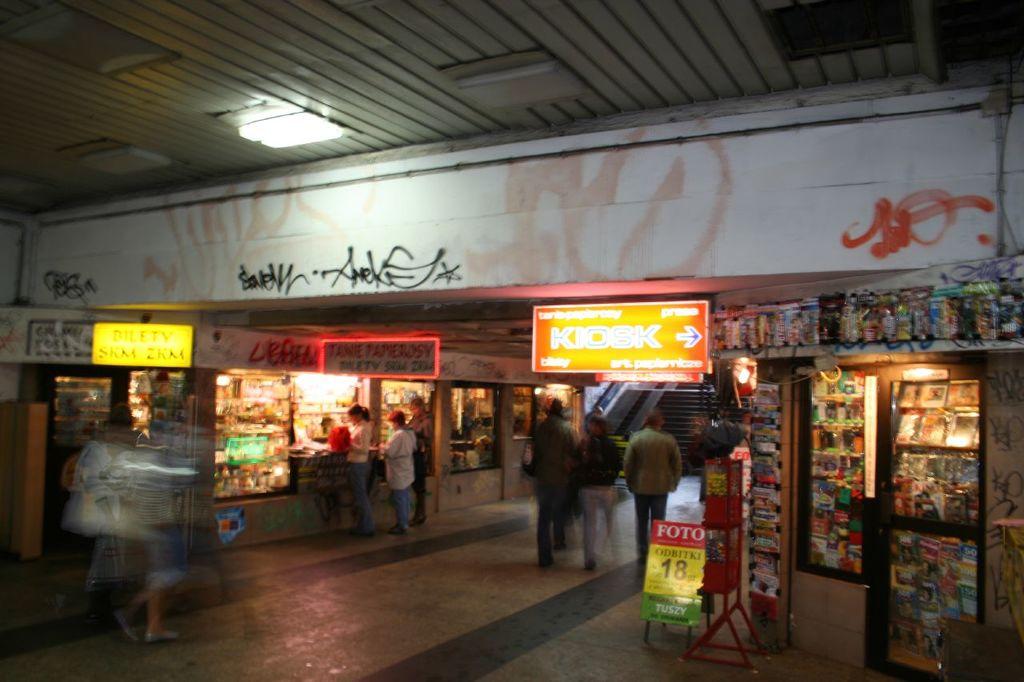Where is the kiosk?
Offer a very short reply. To the right. What does the arrow indicate is to the right on the orange sign?
Your response must be concise. Kiosk. 